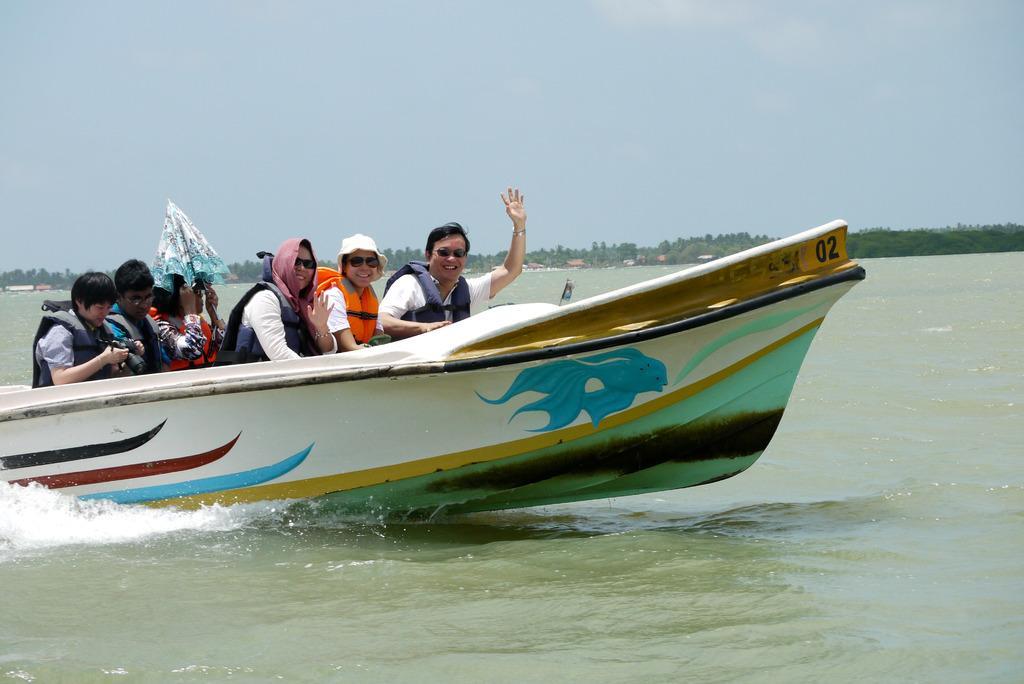Can you describe this image briefly? In the center of the image there is a boat in which there are people. At the bottom of the image there is water. In the background of the image there are trees. At the top of the image there is sky. 